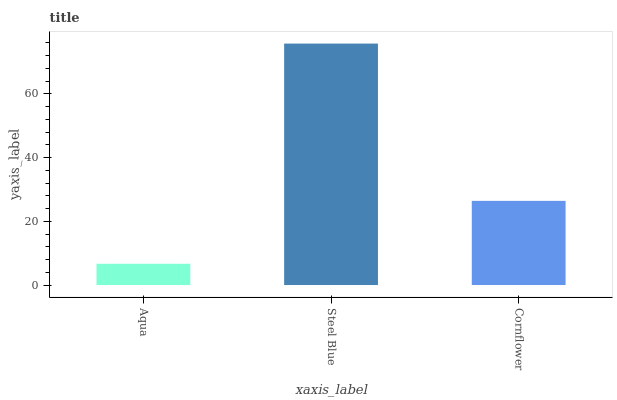Is Aqua the minimum?
Answer yes or no. Yes. Is Steel Blue the maximum?
Answer yes or no. Yes. Is Cornflower the minimum?
Answer yes or no. No. Is Cornflower the maximum?
Answer yes or no. No. Is Steel Blue greater than Cornflower?
Answer yes or no. Yes. Is Cornflower less than Steel Blue?
Answer yes or no. Yes. Is Cornflower greater than Steel Blue?
Answer yes or no. No. Is Steel Blue less than Cornflower?
Answer yes or no. No. Is Cornflower the high median?
Answer yes or no. Yes. Is Cornflower the low median?
Answer yes or no. Yes. Is Aqua the high median?
Answer yes or no. No. Is Steel Blue the low median?
Answer yes or no. No. 